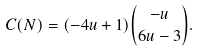<formula> <loc_0><loc_0><loc_500><loc_500>C ( N ) = ( - 4 u + 1 ) \binom { - u } { 6 u - 3 } .</formula> 